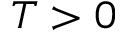<formula> <loc_0><loc_0><loc_500><loc_500>T > 0</formula> 